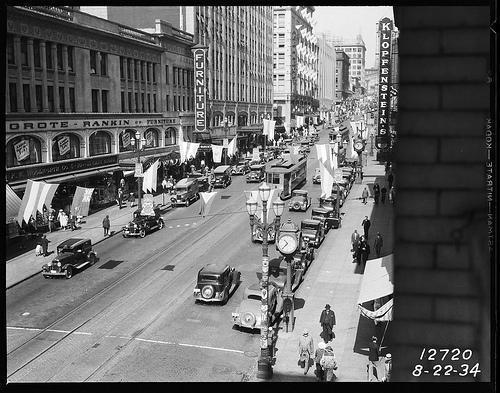How many people are in the picture?
Give a very brief answer. 1. 